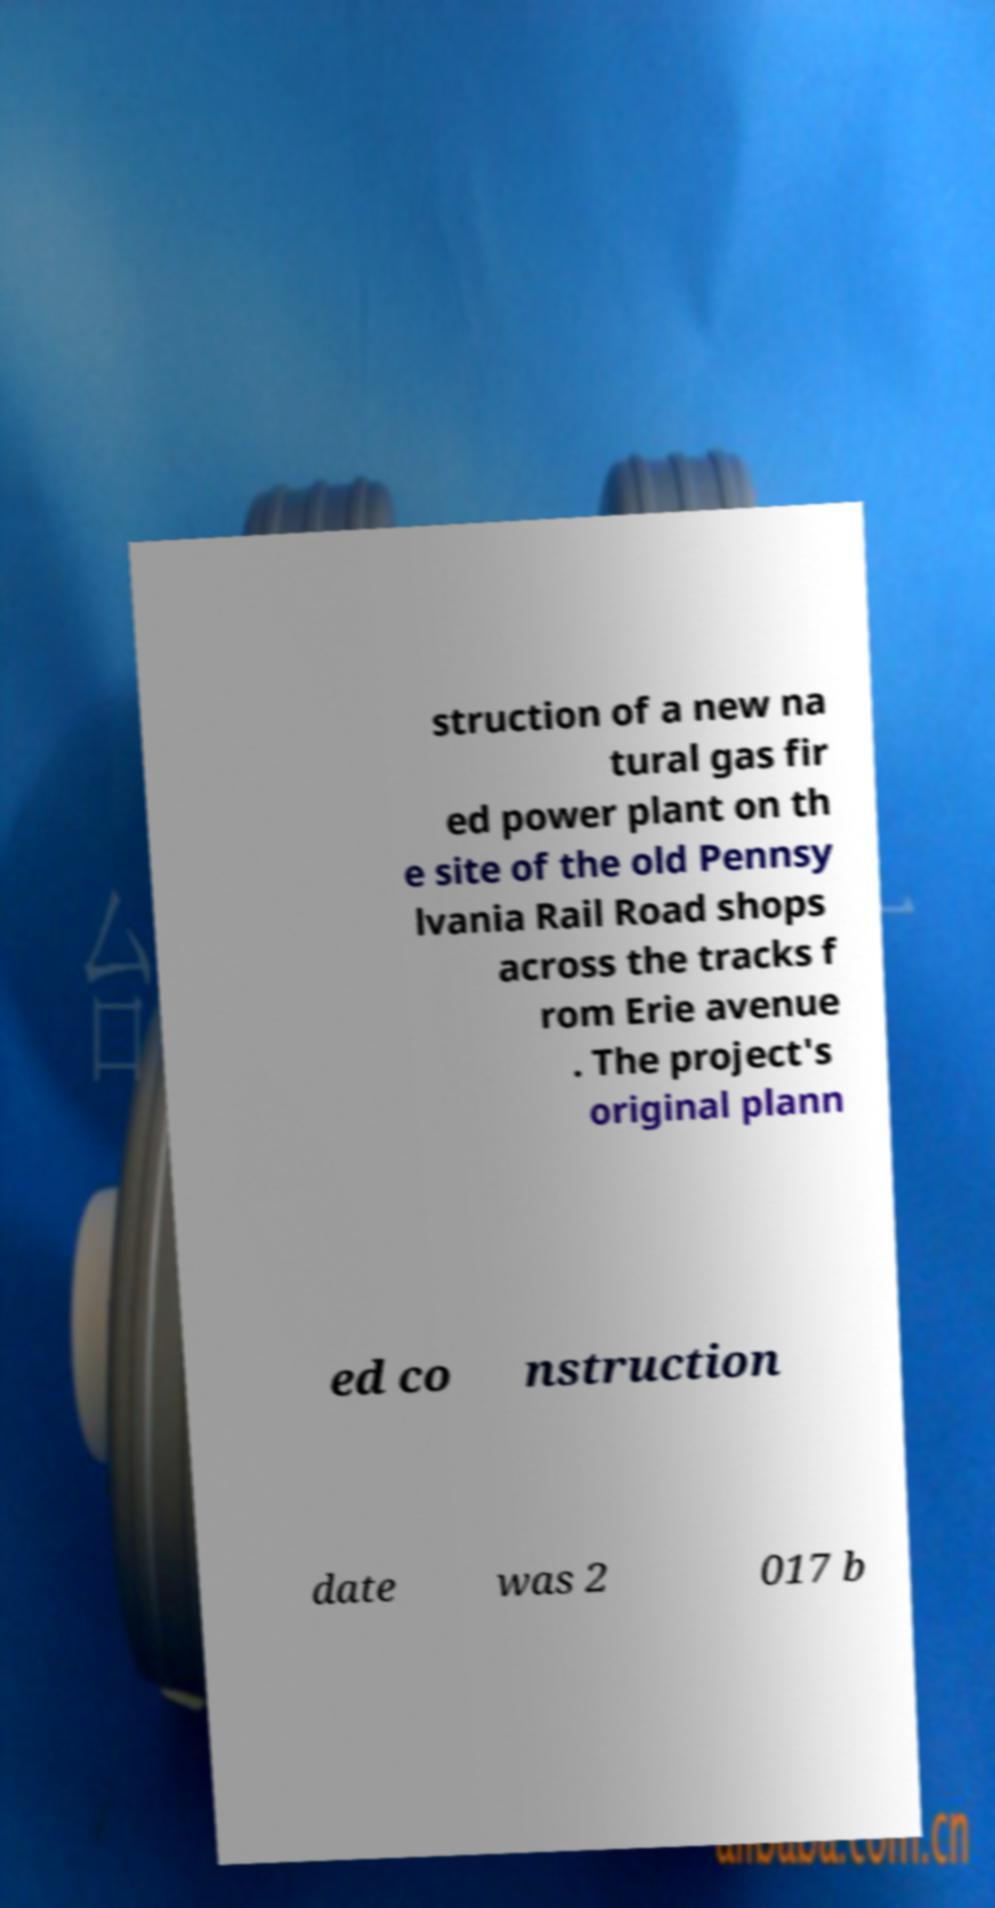What messages or text are displayed in this image? I need them in a readable, typed format. struction of a new na tural gas fir ed power plant on th e site of the old Pennsy lvania Rail Road shops across the tracks f rom Erie avenue . The project's original plann ed co nstruction date was 2 017 b 